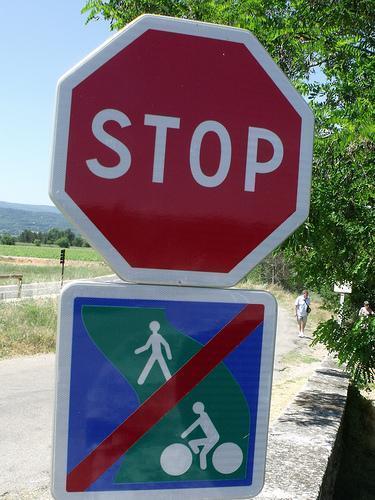How many signs are shown?
Give a very brief answer. 2. 